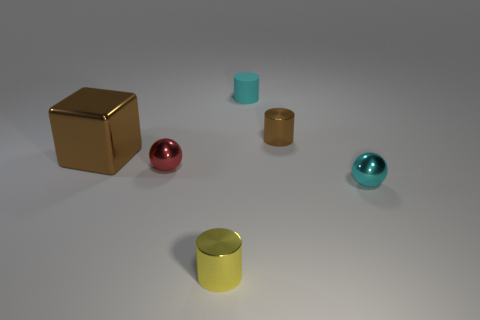Are there any large green rubber cubes?
Ensure brevity in your answer.  No. What number of other things are the same shape as the small matte object?
Offer a terse response. 2. Do the shiny cylinder to the right of the small cyan cylinder and the small ball that is left of the small yellow metallic cylinder have the same color?
Keep it short and to the point. No. There is a brown metal object on the left side of the tiny shiny object that is behind the sphere that is left of the cyan matte cylinder; what size is it?
Your response must be concise. Large. There is a small thing that is behind the small red metallic sphere and in front of the cyan matte object; what shape is it?
Your response must be concise. Cylinder. Are there an equal number of brown shiny blocks right of the small cyan metal ball and metal cylinders that are in front of the brown metallic cylinder?
Ensure brevity in your answer.  No. Are there any small things made of the same material as the red ball?
Your answer should be compact. Yes. Is the small cyan thing that is on the right side of the rubber cylinder made of the same material as the yellow object?
Your answer should be very brief. Yes. What is the size of the metallic thing that is to the right of the matte cylinder and to the left of the cyan metal object?
Keep it short and to the point. Small. What is the color of the small rubber object?
Give a very brief answer. Cyan. 